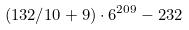Convert formula to latex. <formula><loc_0><loc_0><loc_500><loc_500>( 1 3 2 / 1 0 + 9 ) \cdot 6 ^ { 2 0 9 } - 2 3 2</formula> 